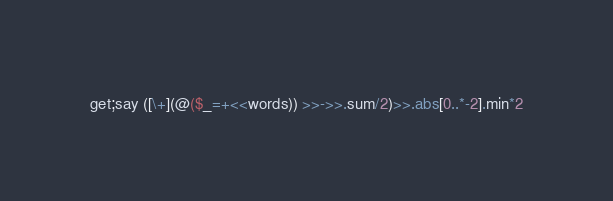Convert code to text. <code><loc_0><loc_0><loc_500><loc_500><_Perl_>get;say ([\+](@($_=+<<words)) >>->>.sum/2)>>.abs[0..*-2].min*2</code> 